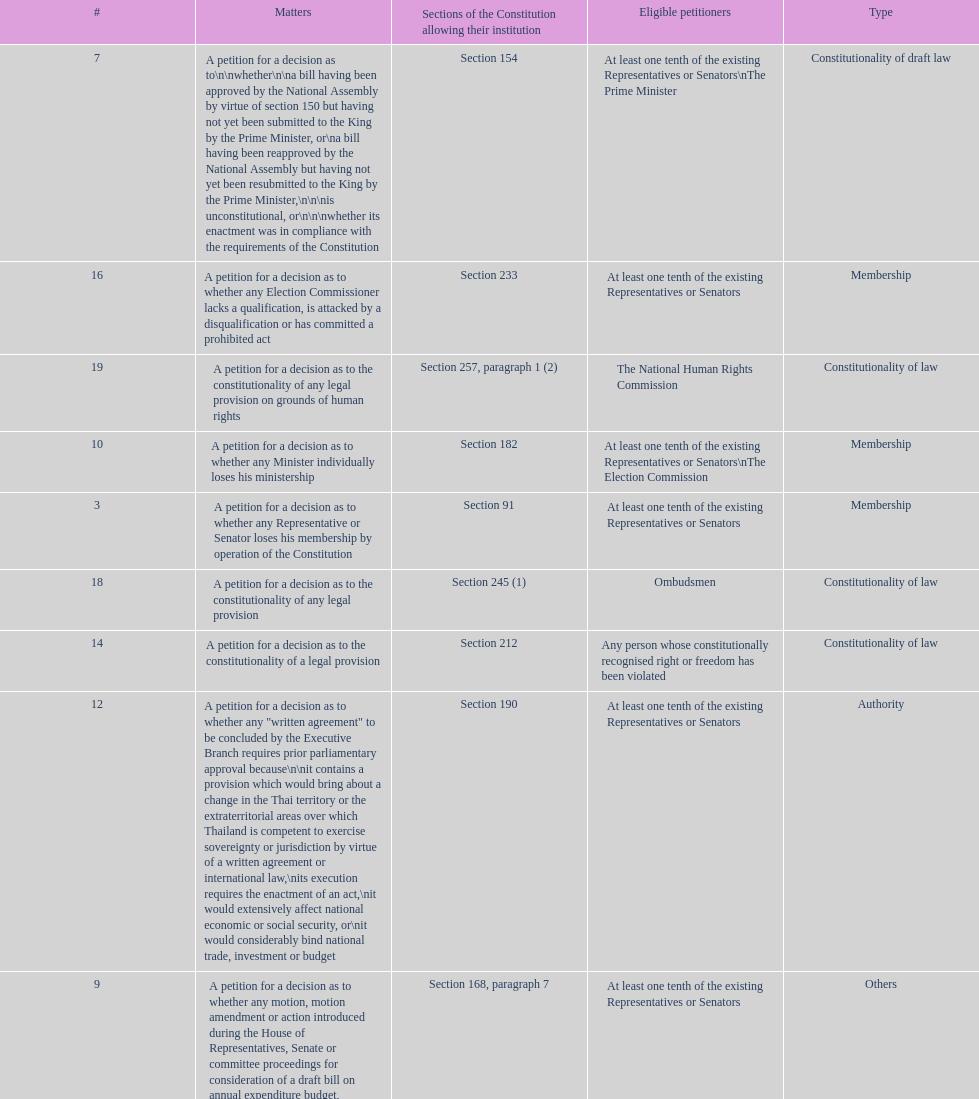Any person can petition matters 2 and 17. true or false? True. 